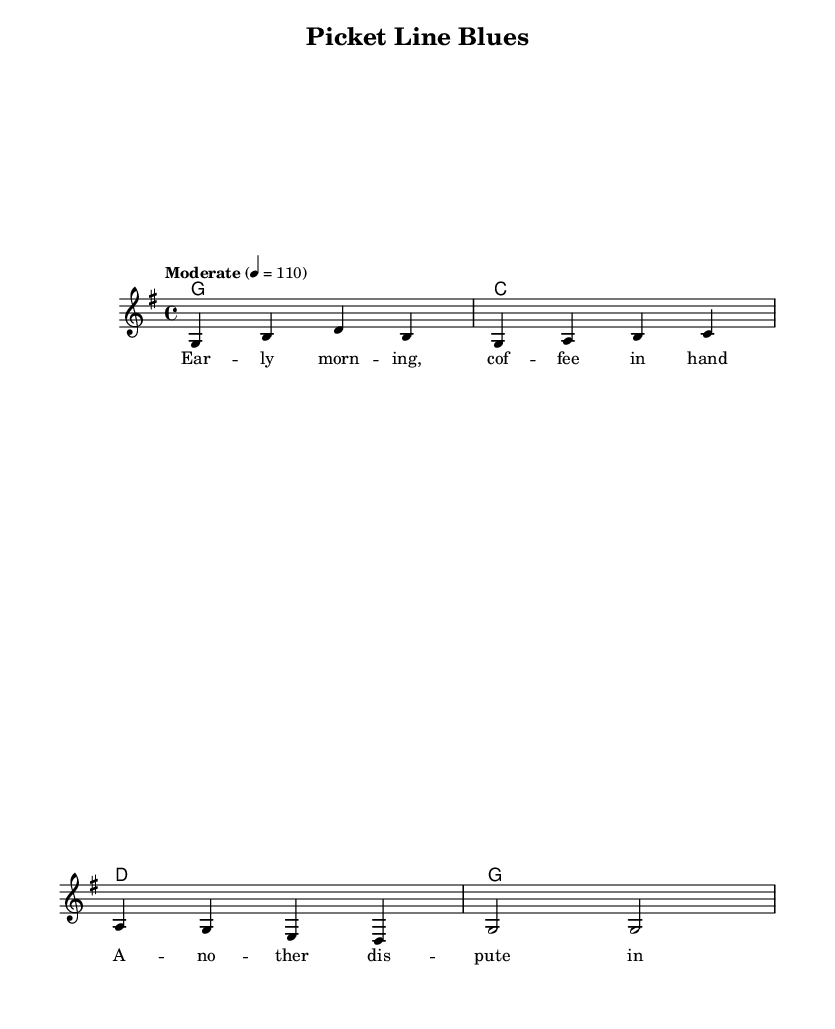What is the key signature of this music? The key signature is G major, which has one sharp (F#) indicated at the beginning of the staves.
Answer: G major What is the time signature of this music? The time signature is indicated as 4/4, meaning there are four beats in each measure, and the quarter note gets one beat.
Answer: 4/4 What tempo marking is provided for this piece? The tempo marking specifies "Moderate" and a metronome setting of 110 beats per minute, which guides the musicians on how fast to play the piece.
Answer: Moderate, 110 How many measures are in the section of the music? The music provided contains four measures, each containing a set of notes and chords.
Answer: 4 What is the first lyric line of the song? The first lyric line is "Ear -- ly morn -- ing, cof -- fee in hand," which introduces the narrative of daily life for the labor mediator.
Answer: Ear -- ly morn -- ing, cof -- fee in hand Which chord follows the G major chord in the harmonies? The chord progression indicates that after the G major chord, it moves to the C major chord.
Answer: C major What thematic element is represented in the lyrics of the song? The lyrics convey a typical scenario faced by a labor mediator, featuring daily routines and disputes reflecting workplace challenges.
Answer: Daily life challenges 